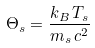Convert formula to latex. <formula><loc_0><loc_0><loc_500><loc_500>\Theta _ { s } = \frac { k _ { B } \, T _ { s } } { m _ { s } \, c ^ { 2 } }</formula> 